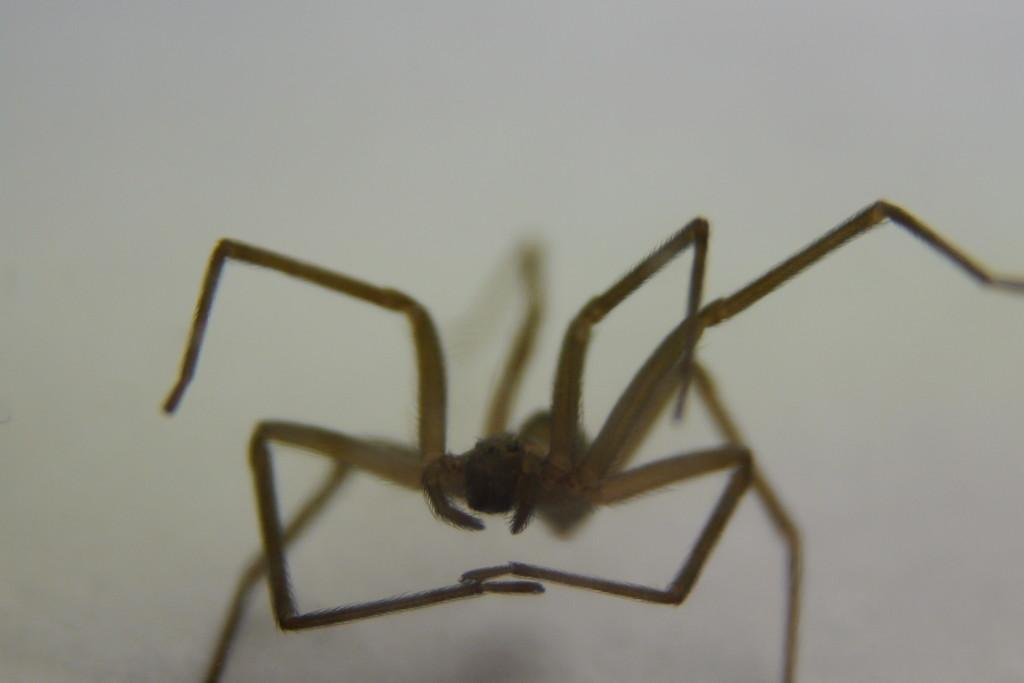What is the main subject of the image? There is a spider in the image. What color is the background of the image? The background of the image is white. How many clocks are present in the image? There are there any signs of disgust? 